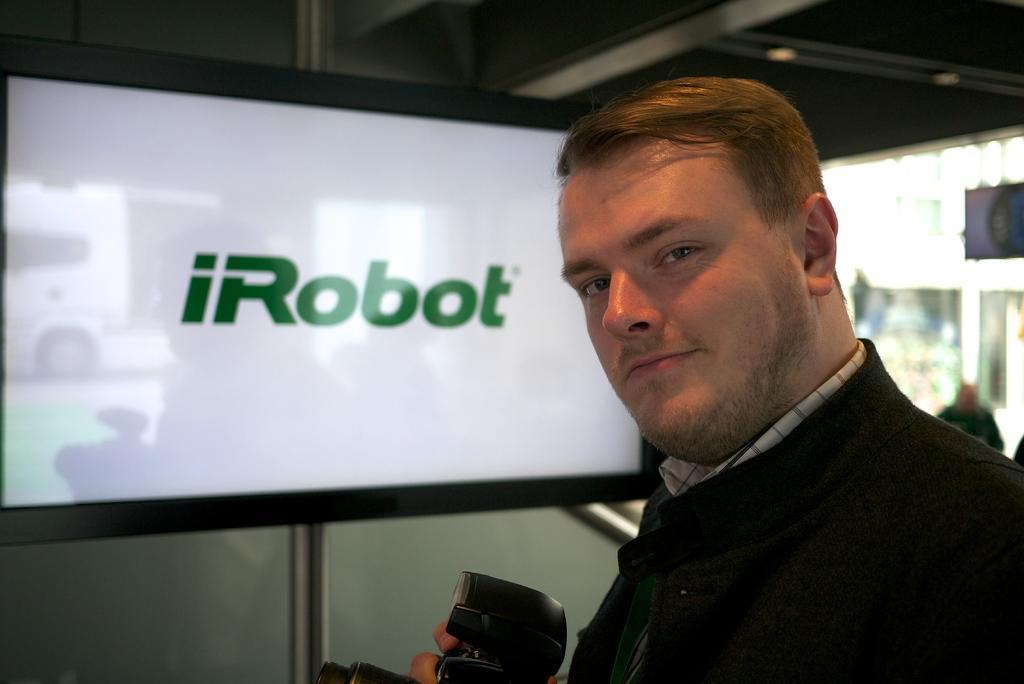How would you summarize this image in a sentence or two? In this picture we can see a man holding a camera with his hand and smiling and in the background we can see a person, screen on the wall and some objects. 